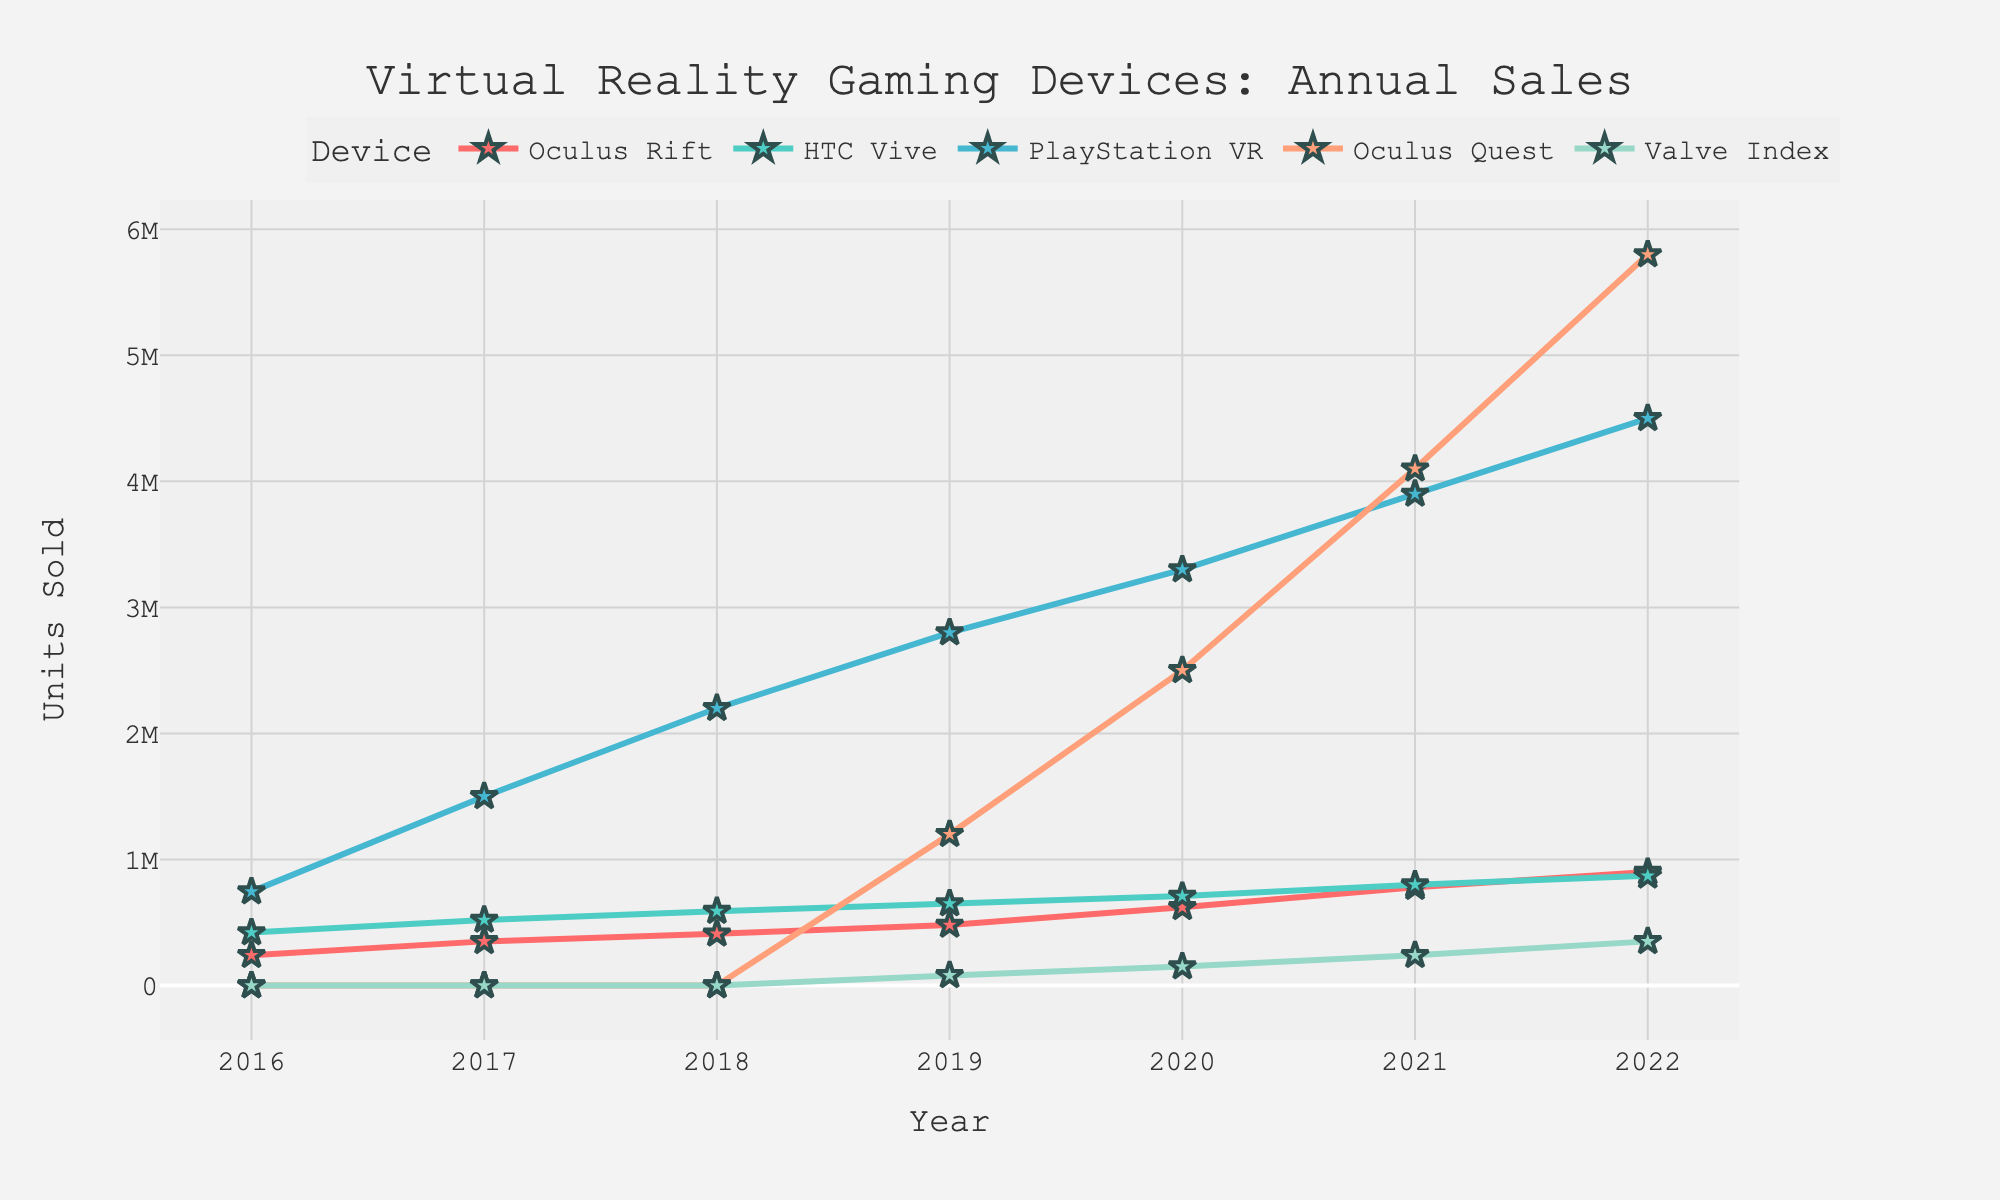What's the total number of PlayStation VR units sold in 2018 and 2019? First, locate the sales numbers for PlayStation VR in 2018 (2,200,000 units) and 2019 (2,800,000 units). Adding these numbers together, 2,200,000 + 2,800,000, gives the total sales.
Answer: 5,000,000 Which year did the Oculus Quest surpass the total sales of HTC Vive? Compare the sales numbers for Oculus Quest and HTC Vive across each year from the data. The Oculus Quest first surpasses HTC Vive in 2020 with 2,500,000 units compared to 710,000 units for HTC Vive.
Answer: 2020 Which device saw the largest increase in sales between 2019 and 2020? Calculate the sales increase for each device between 2019 and 2020. Oculus Rift increased by 140,000 units, HTC Vive by 60,000 units, PlayStation VR by 500,000 units, Oculus Quest by 1,300,000 units, and Valve Index by 70,000 units. The Oculus Quest had the largest increase.
Answer: Oculus Quest What is the average number of units sold annually for HTC Vive from 2018 to 2020? Summing HTC Vive's sales figures for 2018 (590,000), 2019 (650,000), and 2020 (710,000) gives 1,950,000. Dividing by 3 years results in an average of 1,950,000 / 3.
Answer: 650,000 How do the sales of Oculus Rift in 2020 compare with those in 2016? In 2020, the sales for Oculus Rift were 620,000 units, while in 2016, they were 240,000 units. Therefore, sales in 2020 are greater than those in 2016.
Answer: Greater Which device had the least number of units sold in 2019? Comparing the sales numbers for all devices in 2019: Oculus Rift (480,000), HTC Vive (650,000), PlayStation VR (2,800,000), Oculus Quest (1,200,000), and Valve Index (80,000), the Valve Index had the least units sold.
Answer: Valve Index In which year did PlayStation VR achieve the highest sales? Looking at the annual sales figures for PlayStation VR, the highest sales occurred in 2022 with 4,500,000 units.
Answer: 2022 What's the total number of units sold for all devices in 2021? Summing the units sold for all devices in 2021 — Oculus Rift (780,000), HTC Vive (800,000), PlayStation VR (3,900,000), Oculus Quest (4,100,000), and Valve Index (240,000) — results in a total of 9,820,000 units.
Answer: 9,820,000 Which device had a steady increase in sales every year? Visual inspection of the plot shows that both PlayStation VR and Oculus Quest have a steady increase in sales every year from their introduction.
Answer: PlayStation VR and Oculus Quest 